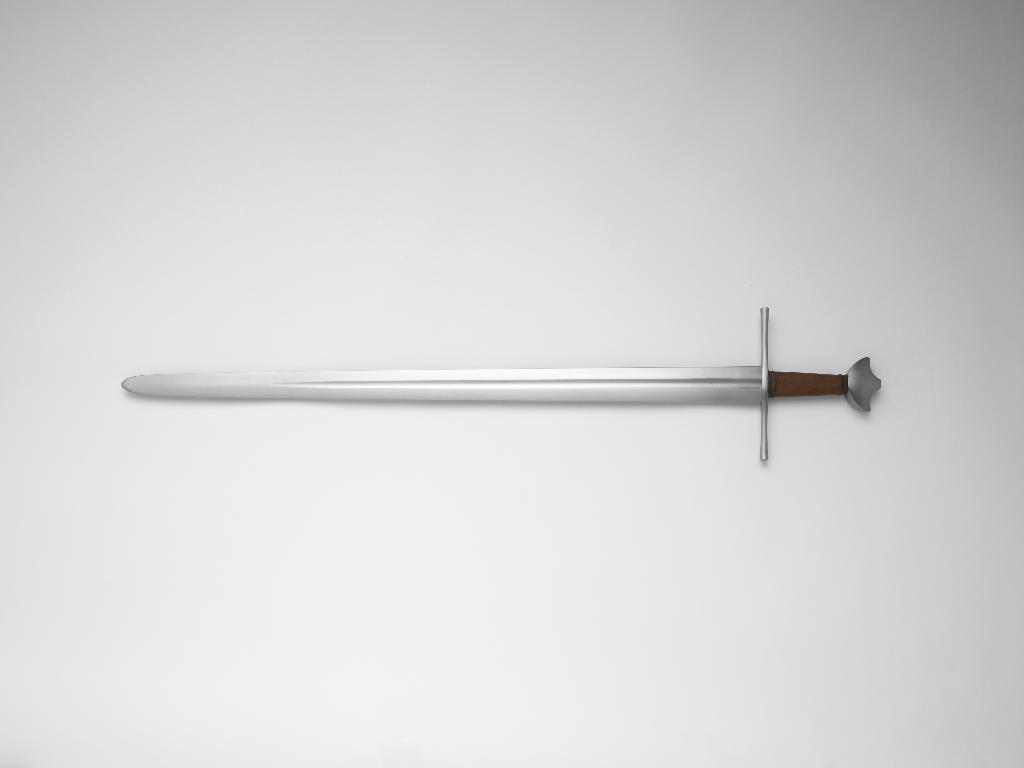What is the main object in the picture? There is a sword in the picture. What can be said about the handle of the sword? The sword has a brown color handle. On what surface is the sword placed? The sword is placed on a white surface. Can you tell me how many ears are visible on the sword in the image? There are no ears present on the sword in the image; it is a sword with a handle and a blade. 